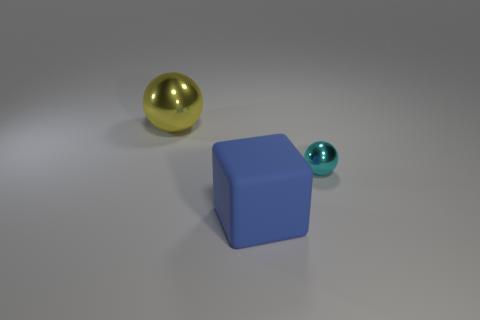Are there any other things that have the same material as the big blue thing?
Offer a very short reply. No. Does the sphere that is left of the blue matte cube have the same size as the blue matte block?
Offer a terse response. Yes. How many big things are either gray things or blue matte things?
Ensure brevity in your answer.  1. Are there any cubes of the same color as the rubber object?
Your response must be concise. No. What is the shape of the metal object that is the same size as the rubber thing?
Ensure brevity in your answer.  Sphere. There is a large object that is in front of the tiny cyan thing; does it have the same color as the tiny metal ball?
Your answer should be compact. No. How many objects are shiny spheres left of the rubber object or yellow rubber blocks?
Your response must be concise. 1. Are there more big things to the right of the yellow metallic ball than yellow metal objects that are left of the block?
Offer a very short reply. No. Does the big yellow object have the same material as the small sphere?
Ensure brevity in your answer.  Yes. There is a thing that is behind the cube and left of the small cyan shiny thing; what is its shape?
Your response must be concise. Sphere. 